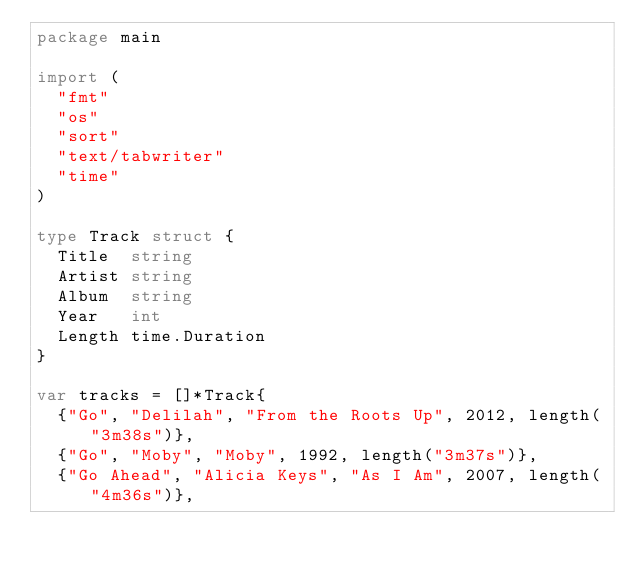<code> <loc_0><loc_0><loc_500><loc_500><_Go_>package main

import (
	"fmt"
	"os"
	"sort"
	"text/tabwriter"
	"time"
)

type Track struct {
	Title  string
	Artist string
	Album  string
	Year   int
	Length time.Duration
}

var tracks = []*Track{
	{"Go", "Delilah", "From the Roots Up", 2012, length("3m38s")},
	{"Go", "Moby", "Moby", 1992, length("3m37s")},
	{"Go Ahead", "Alicia Keys", "As I Am", 2007, length("4m36s")},</code> 